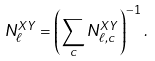Convert formula to latex. <formula><loc_0><loc_0><loc_500><loc_500>N ^ { X Y } _ { \ell } = \left ( \sum _ { c } N ^ { X Y } _ { \ell , c } \right ) ^ { - 1 } .</formula> 